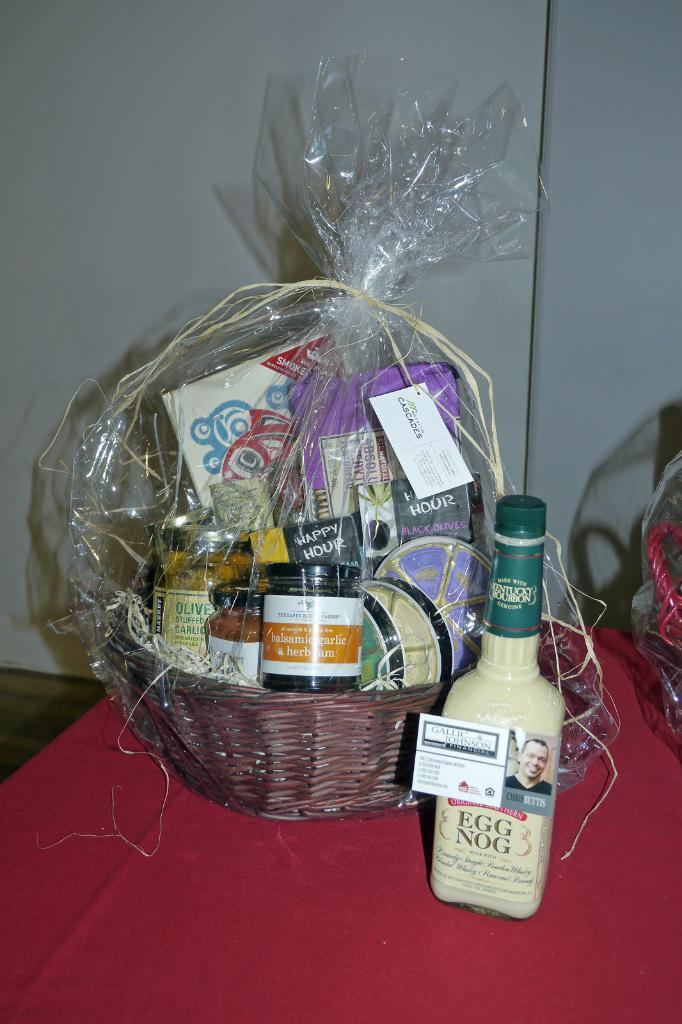<image>
Provide a brief description of the given image. A bottle of egg nog donated by Gallic & Johnson sit next to a gift basket. 